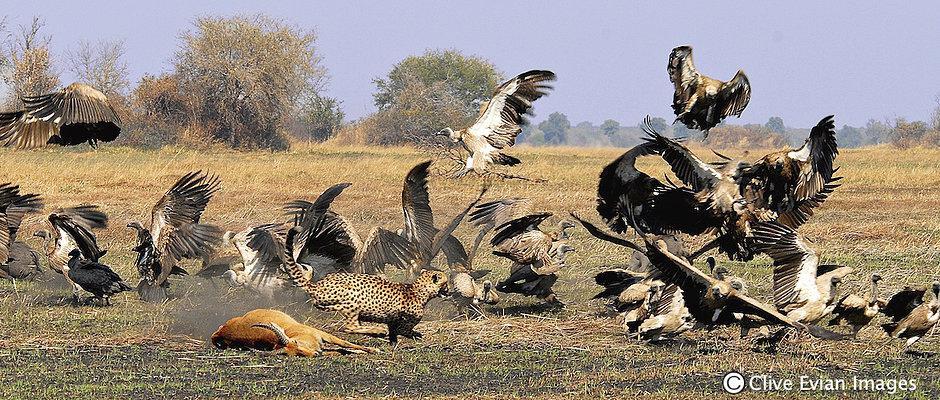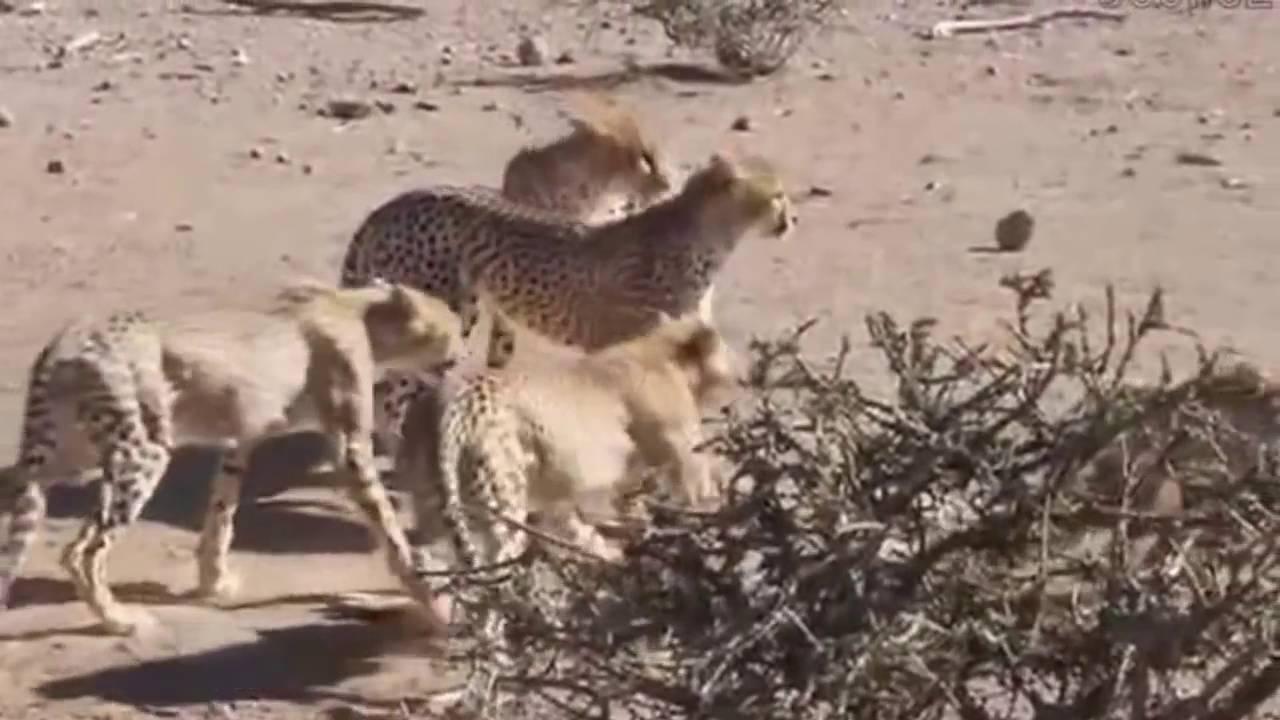The first image is the image on the left, the second image is the image on the right. Considering the images on both sides, is "There are two cheetahs eat pry as a wall of at least 10 vulture wait to get the leftovers." valid? Answer yes or no. No. The first image is the image on the left, the second image is the image on the right. For the images displayed, is the sentence "At least one vulture is in the air." factually correct? Answer yes or no. Yes. 